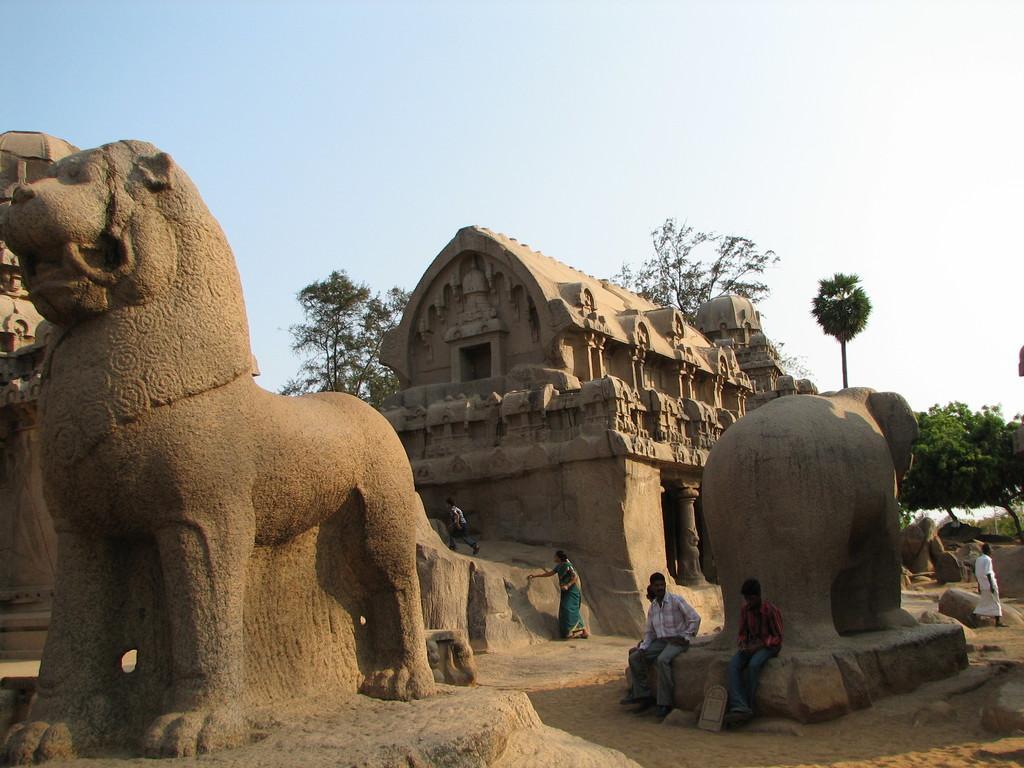How would you summarize this image in a sentence or two? In this image we can see sculpture. Also there are few people. And there is a building with pillars. Also there are trees and there is sky. 